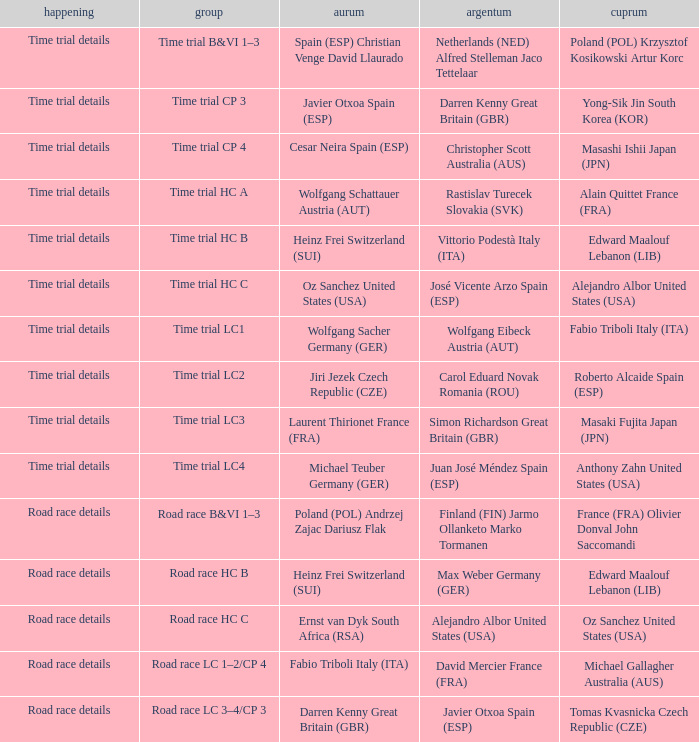Parse the full table. {'header': ['happening', 'group', 'aurum', 'argentum', 'cuprum'], 'rows': [['Time trial details', 'Time trial B&VI 1–3', 'Spain (ESP) Christian Venge David Llaurado', 'Netherlands (NED) Alfred Stelleman Jaco Tettelaar', 'Poland (POL) Krzysztof Kosikowski Artur Korc'], ['Time trial details', 'Time trial CP 3', 'Javier Otxoa Spain (ESP)', 'Darren Kenny Great Britain (GBR)', 'Yong-Sik Jin South Korea (KOR)'], ['Time trial details', 'Time trial CP 4', 'Cesar Neira Spain (ESP)', 'Christopher Scott Australia (AUS)', 'Masashi Ishii Japan (JPN)'], ['Time trial details', 'Time trial HC A', 'Wolfgang Schattauer Austria (AUT)', 'Rastislav Turecek Slovakia (SVK)', 'Alain Quittet France (FRA)'], ['Time trial details', 'Time trial HC B', 'Heinz Frei Switzerland (SUI)', 'Vittorio Podestà Italy (ITA)', 'Edward Maalouf Lebanon (LIB)'], ['Time trial details', 'Time trial HC C', 'Oz Sanchez United States (USA)', 'José Vicente Arzo Spain (ESP)', 'Alejandro Albor United States (USA)'], ['Time trial details', 'Time trial LC1', 'Wolfgang Sacher Germany (GER)', 'Wolfgang Eibeck Austria (AUT)', 'Fabio Triboli Italy (ITA)'], ['Time trial details', 'Time trial LC2', 'Jiri Jezek Czech Republic (CZE)', 'Carol Eduard Novak Romania (ROU)', 'Roberto Alcaide Spain (ESP)'], ['Time trial details', 'Time trial LC3', 'Laurent Thirionet France (FRA)', 'Simon Richardson Great Britain (GBR)', 'Masaki Fujita Japan (JPN)'], ['Time trial details', 'Time trial LC4', 'Michael Teuber Germany (GER)', 'Juan José Méndez Spain (ESP)', 'Anthony Zahn United States (USA)'], ['Road race details', 'Road race B&VI 1–3', 'Poland (POL) Andrzej Zajac Dariusz Flak', 'Finland (FIN) Jarmo Ollanketo Marko Tormanen', 'France (FRA) Olivier Donval John Saccomandi'], ['Road race details', 'Road race HC B', 'Heinz Frei Switzerland (SUI)', 'Max Weber Germany (GER)', 'Edward Maalouf Lebanon (LIB)'], ['Road race details', 'Road race HC C', 'Ernst van Dyk South Africa (RSA)', 'Alejandro Albor United States (USA)', 'Oz Sanchez United States (USA)'], ['Road race details', 'Road race LC 1–2/CP 4', 'Fabio Triboli Italy (ITA)', 'David Mercier France (FRA)', 'Michael Gallagher Australia (AUS)'], ['Road race details', 'Road race LC 3–4/CP 3', 'Darren Kenny Great Britain (GBR)', 'Javier Otxoa Spain (ESP)', 'Tomas Kvasnicka Czech Republic (CZE)']]} Who received gold when silver is wolfgang eibeck austria (aut)? Wolfgang Sacher Germany (GER). 